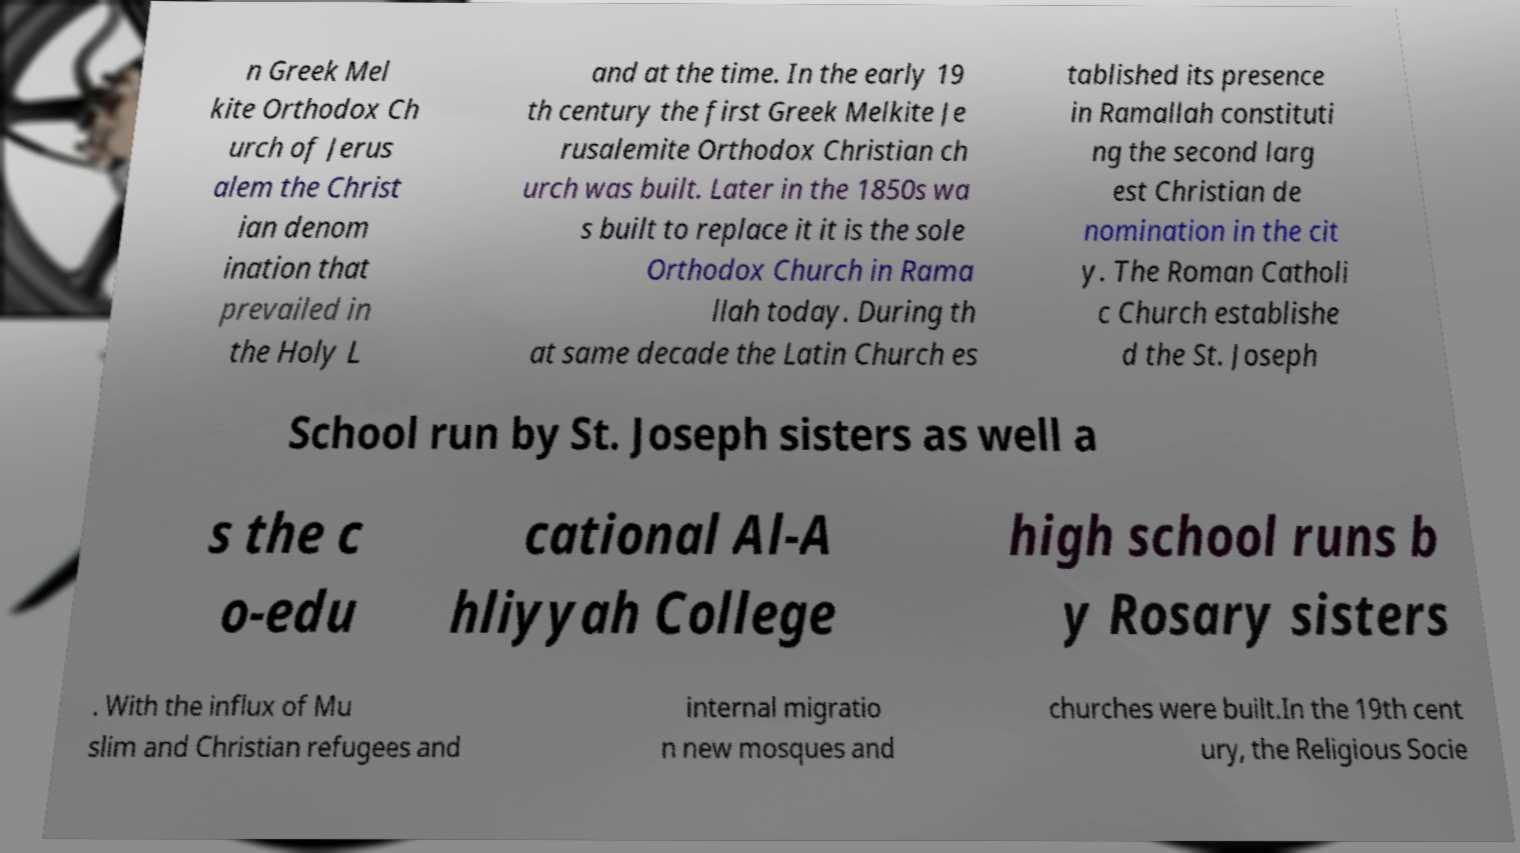Please identify and transcribe the text found in this image. n Greek Mel kite Orthodox Ch urch of Jerus alem the Christ ian denom ination that prevailed in the Holy L and at the time. In the early 19 th century the first Greek Melkite Je rusalemite Orthodox Christian ch urch was built. Later in the 1850s wa s built to replace it it is the sole Orthodox Church in Rama llah today. During th at same decade the Latin Church es tablished its presence in Ramallah constituti ng the second larg est Christian de nomination in the cit y. The Roman Catholi c Church establishe d the St. Joseph School run by St. Joseph sisters as well a s the c o-edu cational Al-A hliyyah College high school runs b y Rosary sisters . With the influx of Mu slim and Christian refugees and internal migratio n new mosques and churches were built.In the 19th cent ury, the Religious Socie 